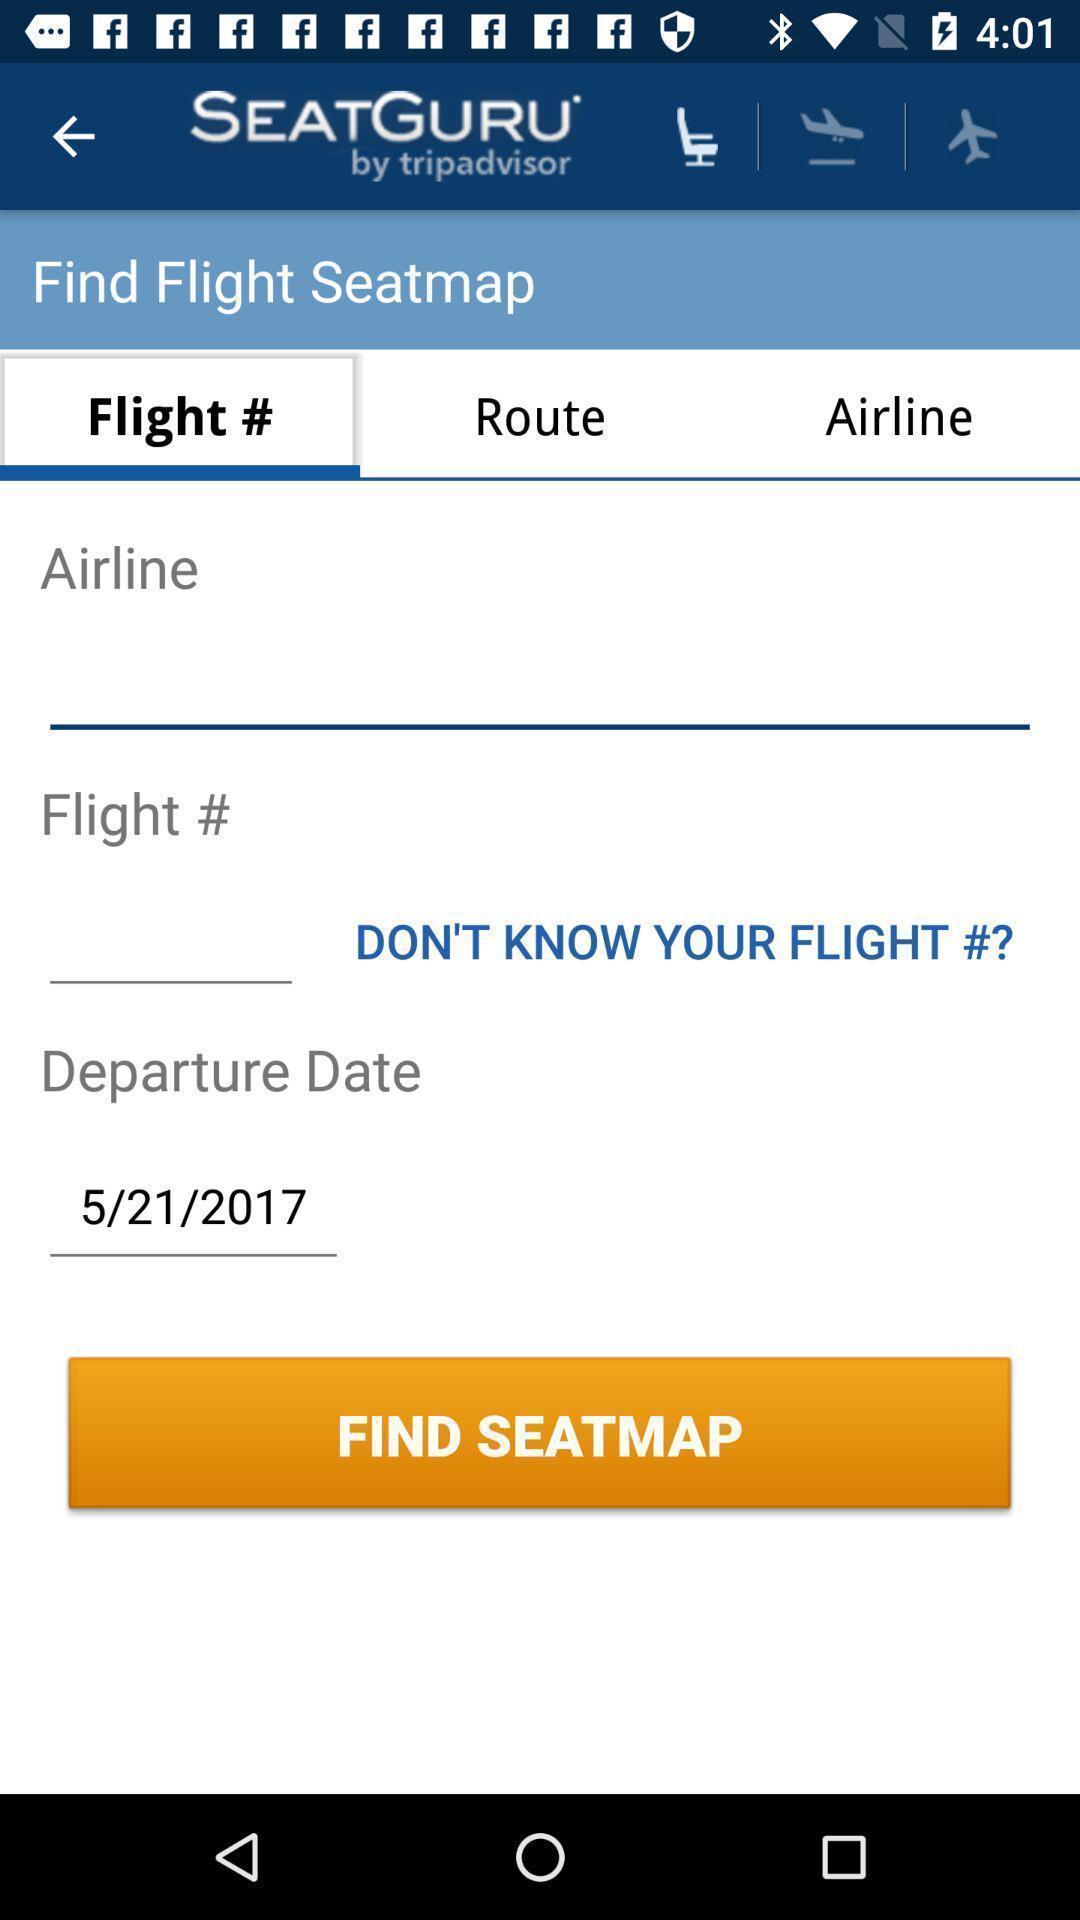Provide a detailed account of this screenshot. Screen displaying multiple options in a flight booking application. 